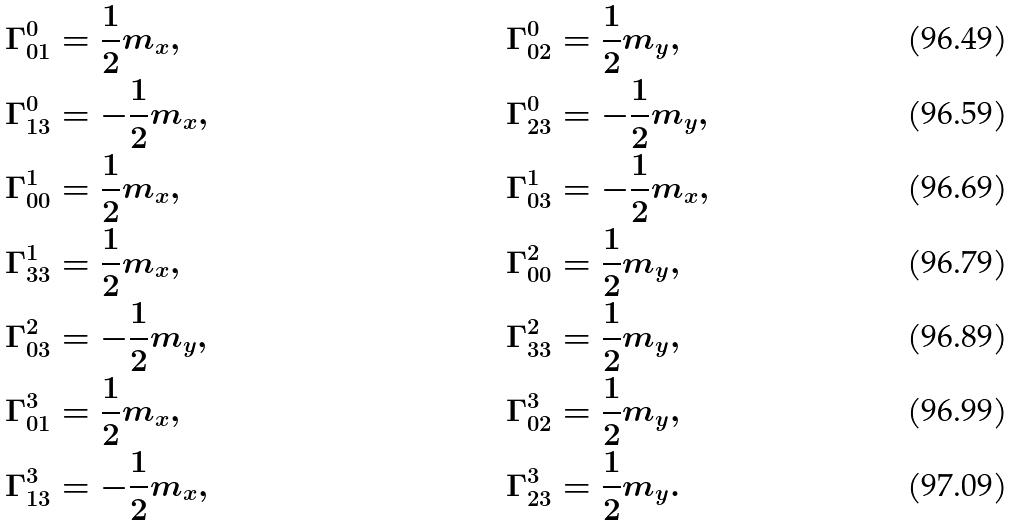<formula> <loc_0><loc_0><loc_500><loc_500>\Gamma _ { 0 1 } ^ { 0 } & = \frac { 1 } { 2 } m _ { x } , & \Gamma _ { 0 2 } ^ { 0 } & = \frac { 1 } { 2 } m _ { y } , \\ \Gamma _ { 1 3 } ^ { 0 } & = - \frac { 1 } { 2 } m _ { x } , & \Gamma _ { 2 3 } ^ { 0 } & = - \frac { 1 } { 2 } m _ { y } , \\ \Gamma _ { 0 0 } ^ { 1 } & = \frac { 1 } { 2 } m _ { x } , & \Gamma _ { 0 3 } ^ { 1 } & = - \frac { 1 } { 2 } m _ { x } , \\ \Gamma _ { 3 3 } ^ { 1 } & = \frac { 1 } { 2 } m _ { x } , & \Gamma _ { 0 0 } ^ { 2 } & = \frac { 1 } { 2 } m _ { y } , \\ \Gamma _ { 0 3 } ^ { 2 } & = - \frac { 1 } { 2 } m _ { y } , & \Gamma _ { 3 3 } ^ { 2 } & = \frac { 1 } { 2 } m _ { y } , \\ \Gamma _ { 0 1 } ^ { 3 } & = \frac { 1 } { 2 } m _ { x } , & \Gamma _ { 0 2 } ^ { 3 } & = \frac { 1 } { 2 } m _ { y } , \\ \Gamma _ { 1 3 } ^ { 3 } & = - \frac { 1 } { 2 } m _ { x } , & \Gamma _ { 2 3 } ^ { 3 } & = \frac { 1 } { 2 } m _ { y } .</formula> 